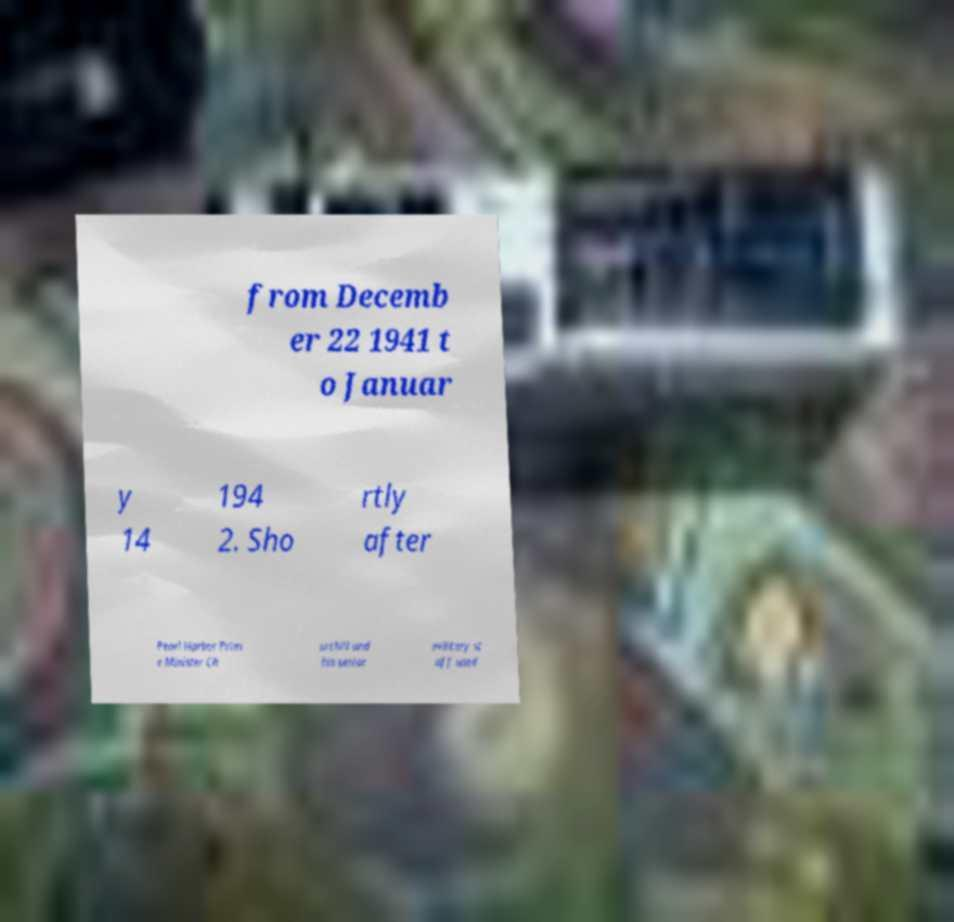There's text embedded in this image that I need extracted. Can you transcribe it verbatim? from Decemb er 22 1941 t o Januar y 14 194 2. Sho rtly after Pearl Harbor Prim e Minister Ch urchill and his senior military st aff used 